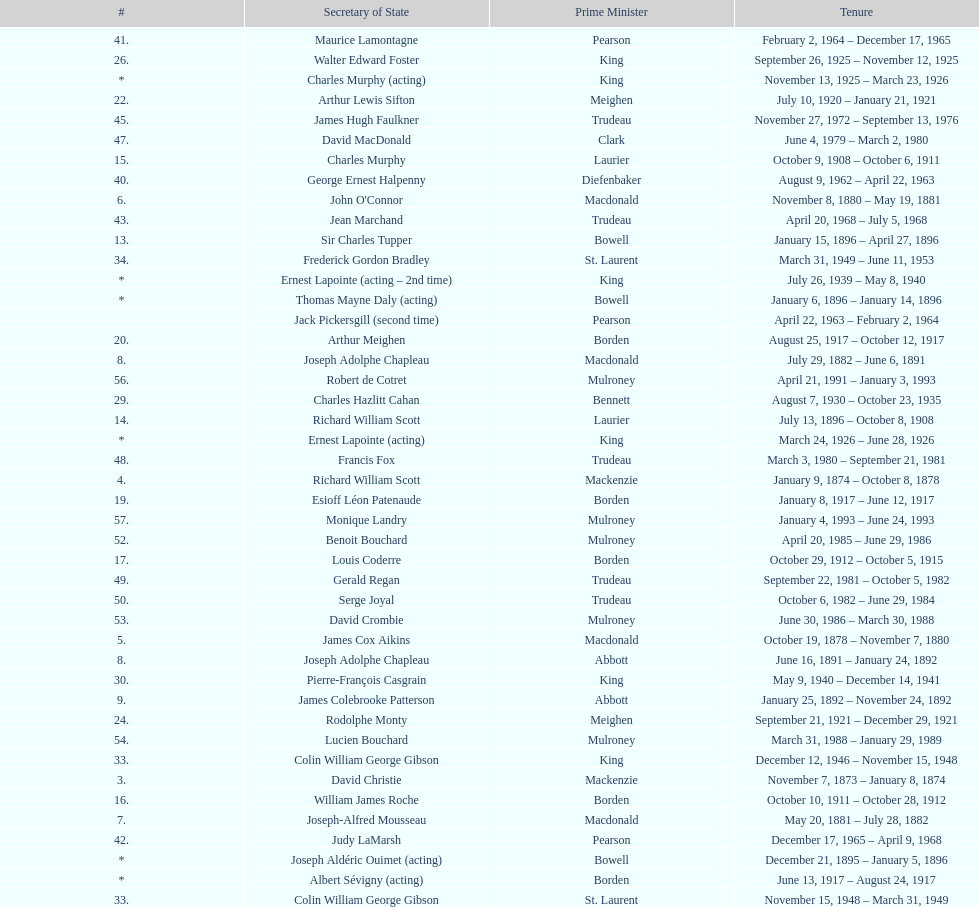Was macdonald prime minister before or after bowell? Before. 